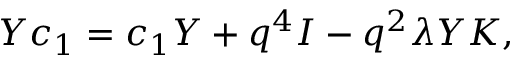<formula> <loc_0><loc_0><loc_500><loc_500>Y c _ { 1 } = c _ { 1 } Y + q ^ { 4 } I - q ^ { 2 } \lambda Y K ,</formula> 